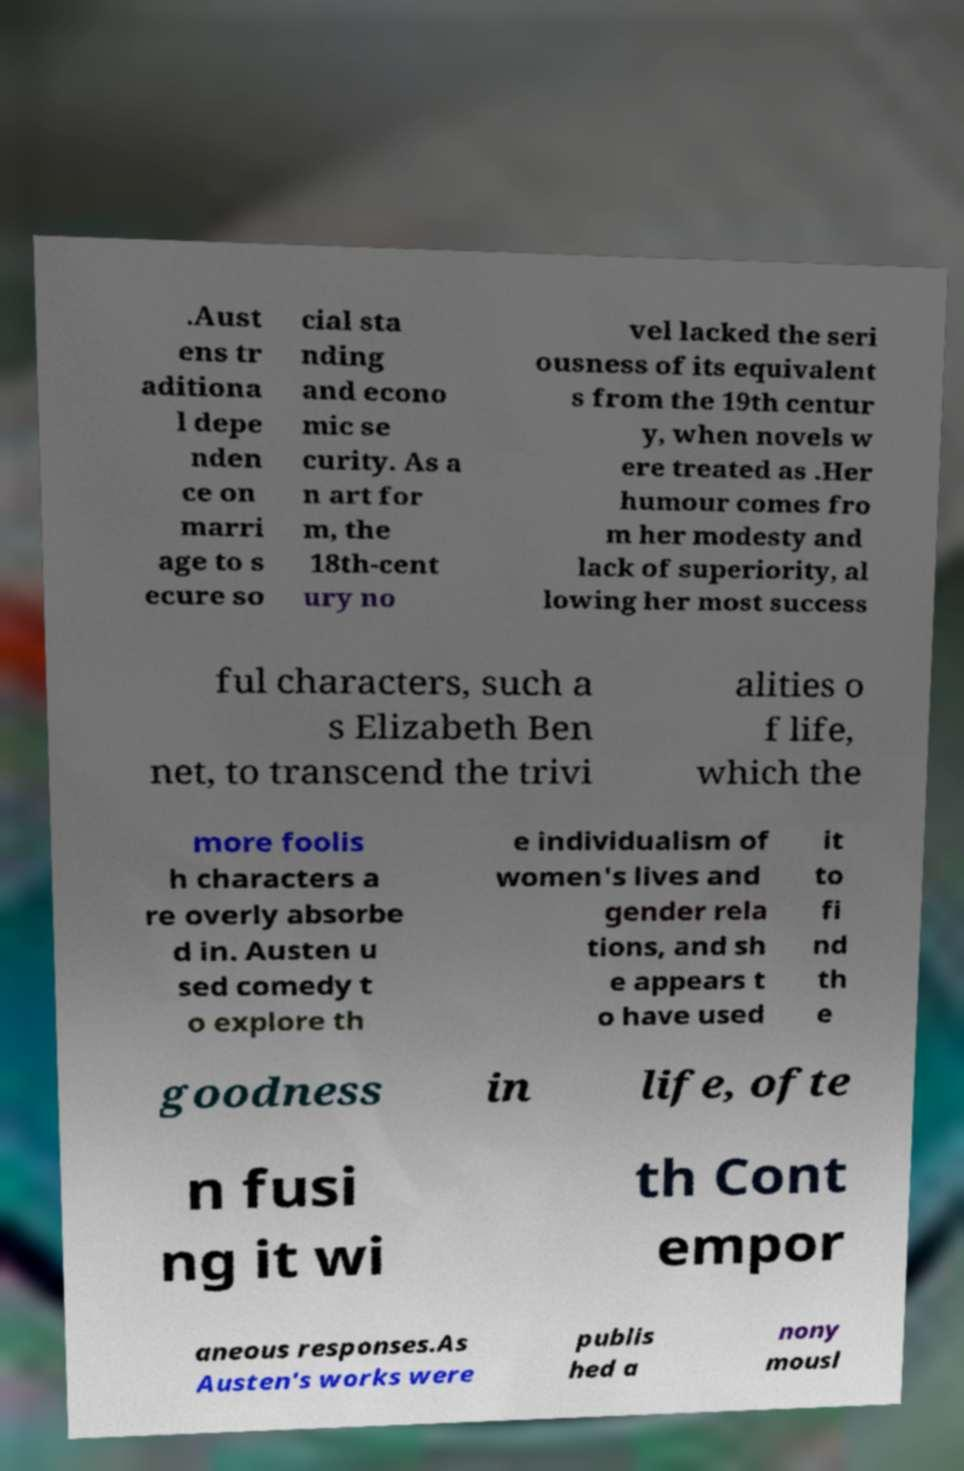I need the written content from this picture converted into text. Can you do that? .Aust ens tr aditiona l depe nden ce on marri age to s ecure so cial sta nding and econo mic se curity. As a n art for m, the 18th-cent ury no vel lacked the seri ousness of its equivalent s from the 19th centur y, when novels w ere treated as .Her humour comes fro m her modesty and lack of superiority, al lowing her most success ful characters, such a s Elizabeth Ben net, to transcend the trivi alities o f life, which the more foolis h characters a re overly absorbe d in. Austen u sed comedy t o explore th e individualism of women's lives and gender rela tions, and sh e appears t o have used it to fi nd th e goodness in life, ofte n fusi ng it wi th Cont empor aneous responses.As Austen's works were publis hed a nony mousl 